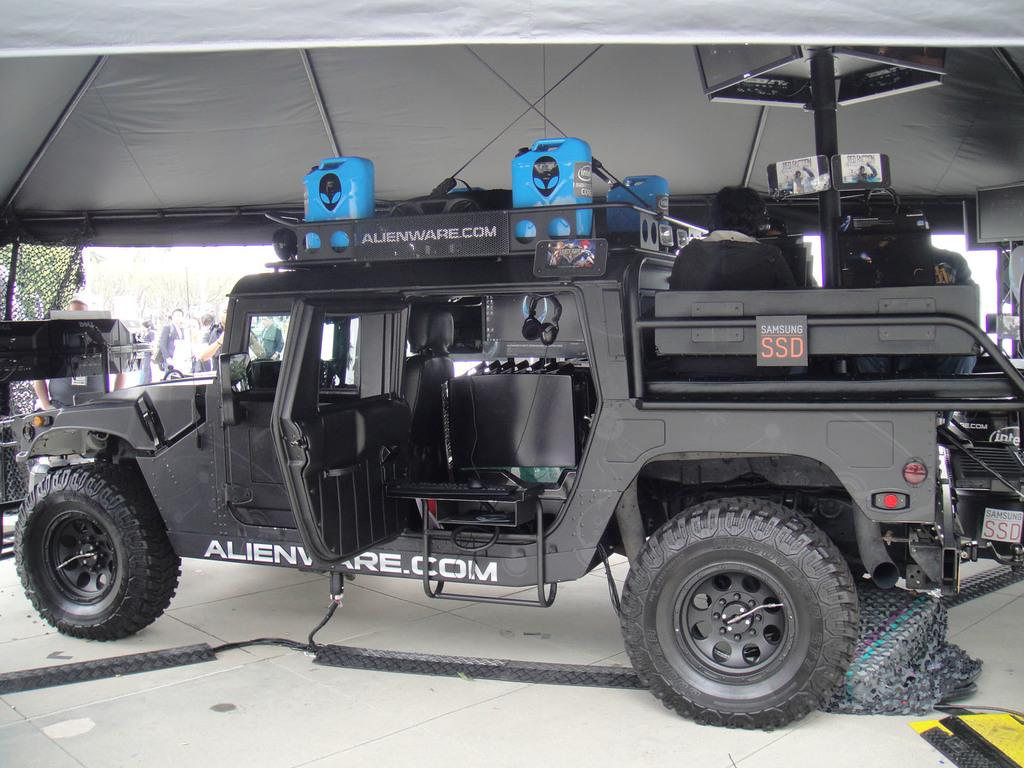What color is the vehicle in the image? The vehicle in the image is black-colored. What structure can be seen at the top of the image? There is a tent at the top of the image. Where are the people located in the image? The people are on the left side of the image. What type of sugar is being used to write on the vehicle? There is no sugar present in the image, and the vehicle is not being used for writing. 